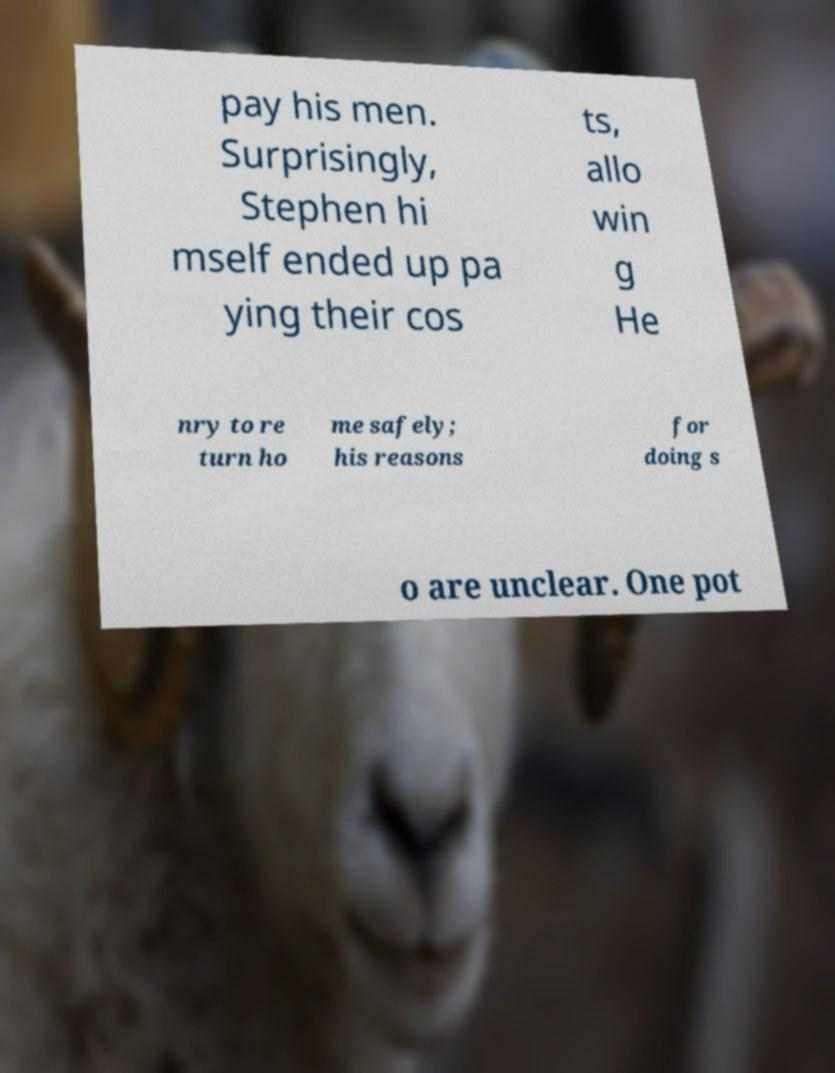I need the written content from this picture converted into text. Can you do that? pay his men. Surprisingly, Stephen hi mself ended up pa ying their cos ts, allo win g He nry to re turn ho me safely; his reasons for doing s o are unclear. One pot 